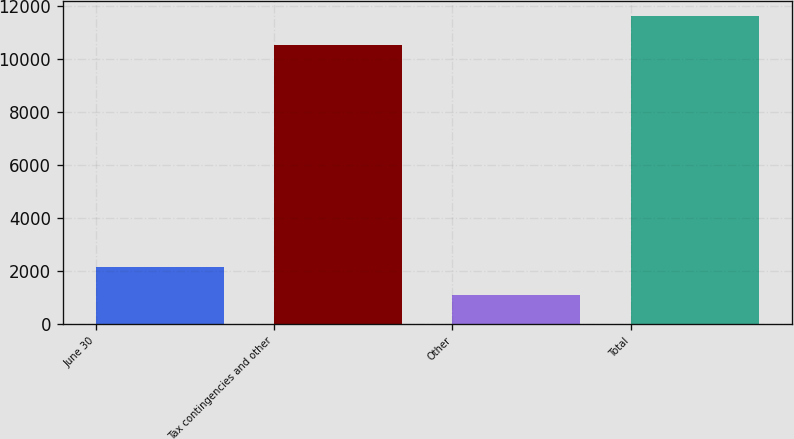Convert chart. <chart><loc_0><loc_0><loc_500><loc_500><bar_chart><fcel>June 30<fcel>Tax contingencies and other<fcel>Other<fcel>Total<nl><fcel>2135<fcel>10510<fcel>1084<fcel>11594<nl></chart> 